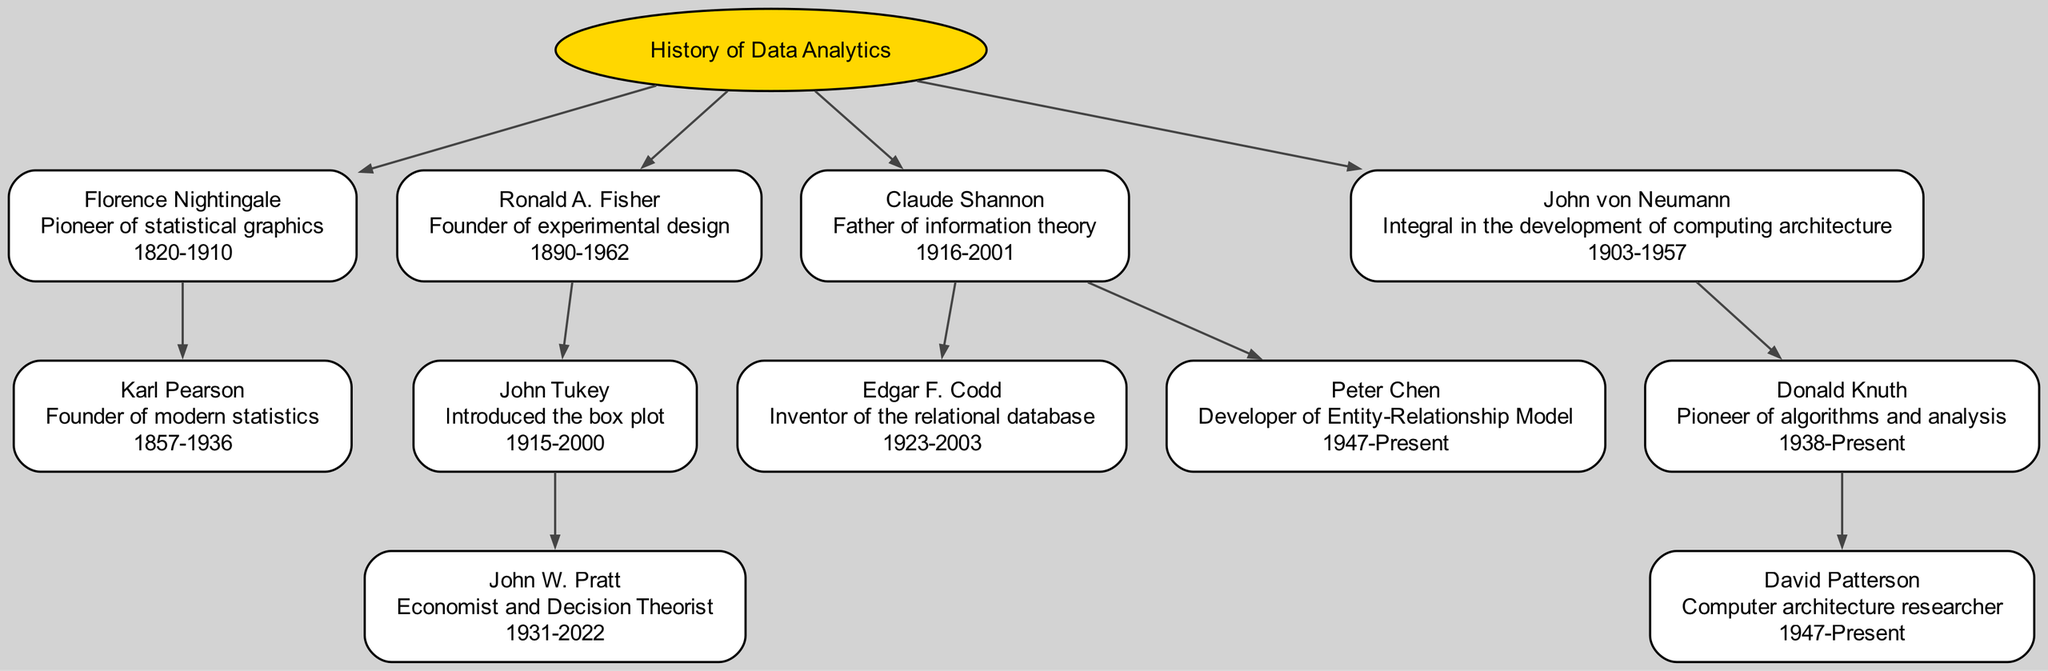What is the lifespan of Florence Nightingale? Referring to the node for Florence Nightingale in the diagram, her lifespan is specified directly as 1820-1910.
Answer: 1820-1910 Who introduced the box plot? The child node under Ronald A. Fisher specifically identifies John Tukey as the individual who introduced the box plot.
Answer: John Tukey How many children does Claude Shannon have? Looking at the children of Claude Shannon, there are two nodes directly connected to him: Edgar F. Codd and Peter Chen. Therefore, he has two children.
Answer: 2 What is the importance of Ronald A. Fisher? The node for Ronald A. Fisher describes him as the founder of experimental design, which is a direct piece of information stated in the diagram.
Answer: Founder of experimental design Who is the parent of John W. Pratt? John W. Pratt is a child node under John Tukey, meaning John Tukey is the parent of John W. Pratt.
Answer: John Tukey Which prominent figure is known as the father of information theory? In the diagram, Claude Shannon is labeled as the father of information theory, which identifies his significance clearly in the context of the family tree.
Answer: Claude Shannon What role did Edgar F. Codd play in data analytics? The node associated with Edgar F. Codd states that he is the inventor of the relational database, which describes his contribution to the field.
Answer: Inventor of the relational database Who are the descendants of John von Neumann? The diagram shows that the only child connected to John von Neumann is Donald Knuth, who further has David Patterson as a child. Therefore, the descendants are Donald Knuth and David Patterson.
Answer: Donald Knuth, David Patterson Which prominent figure is associated with the development of algorithms and analysis? The node for Donald Knuth explicitly states that he is a pioneer in algorithms and analysis, which highlights his role in this area.
Answer: Donald Knuth 